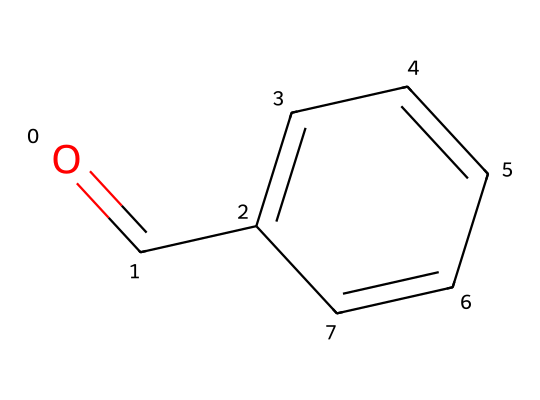How many carbon atoms are in benzaldehyde? In the molecular structure provided, there are six carbon atoms in the aromatic ring (c1ccccc1) plus one carbon from the aldehyde functional group (O=C), making a total of seven carbon atoms.
Answer: seven What is the functional group present in benzaldehyde? The chemical structure shows the carbonyl group (C=O) attached to a carbon atom that is part of an aromatic ring, indicating the presence of an aldehyde functional group.
Answer: aldehyde How many hydrogen atoms are bonded to benzaldehyde? Each of the six carbons in the ring typically bonds with one hydrogen, and the carbonyl carbon in the aldehyde has one hydrogen attached, resulting in a total of five hydrogen atoms connected to the benzaldehyde molecule.
Answer: six What type of aromatic system is benzaldehyde categorized under? The presence of a cyclic structure with alternating double bonds in the carbon atoms indicates that benzaldehyde contains a conjugated planar system, characteristic of aromatic compounds.
Answer: aromatic What is the overall molecular formula for benzaldehyde? By counting the elements from the structure—7 carbons, 6 hydrogens, and 1 oxygen—the molecular formula can be written as C7H6O.
Answer: C7H6O What characteristic scent does benzaldehyde have? The simplified structure of benzaldehyde indicates that it is well-known for its sweet, almond-like scent because of its distinct aromatic characteristics.
Answer: almond What type of chemical reaction is typical for aldehydes like benzaldehyde? Aldehydes can undergo oxidation reactions and participate in nucleophilic addition reactions due to the reactivity of the carbonyl group, which is evident in the structure provided.
Answer: oxidation 